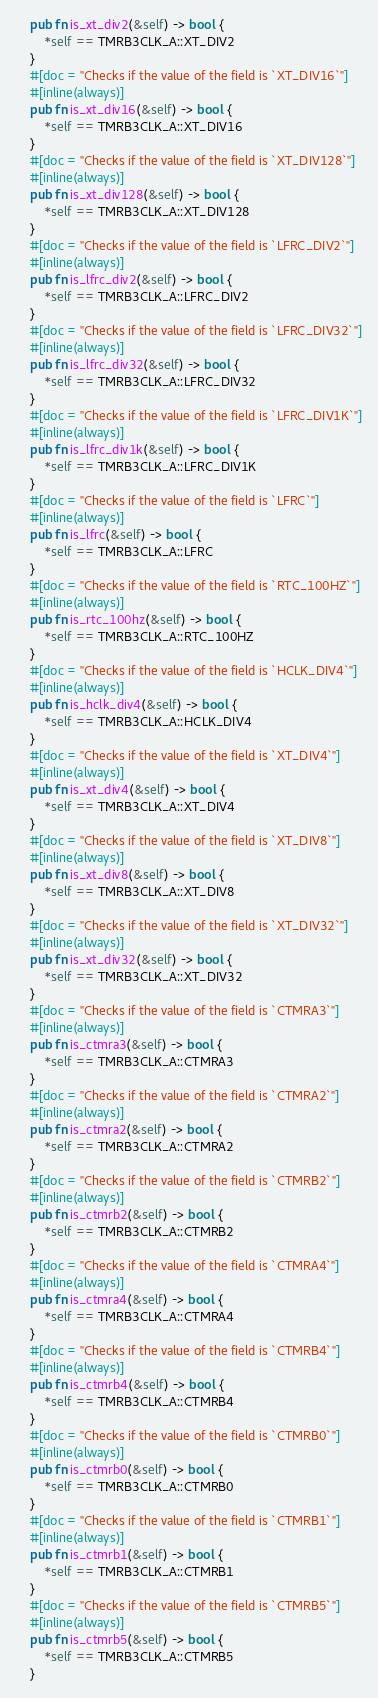<code> <loc_0><loc_0><loc_500><loc_500><_Rust_>    pub fn is_xt_div2(&self) -> bool {
        *self == TMRB3CLK_A::XT_DIV2
    }
    #[doc = "Checks if the value of the field is `XT_DIV16`"]
    #[inline(always)]
    pub fn is_xt_div16(&self) -> bool {
        *self == TMRB3CLK_A::XT_DIV16
    }
    #[doc = "Checks if the value of the field is `XT_DIV128`"]
    #[inline(always)]
    pub fn is_xt_div128(&self) -> bool {
        *self == TMRB3CLK_A::XT_DIV128
    }
    #[doc = "Checks if the value of the field is `LFRC_DIV2`"]
    #[inline(always)]
    pub fn is_lfrc_div2(&self) -> bool {
        *self == TMRB3CLK_A::LFRC_DIV2
    }
    #[doc = "Checks if the value of the field is `LFRC_DIV32`"]
    #[inline(always)]
    pub fn is_lfrc_div32(&self) -> bool {
        *self == TMRB3CLK_A::LFRC_DIV32
    }
    #[doc = "Checks if the value of the field is `LFRC_DIV1K`"]
    #[inline(always)]
    pub fn is_lfrc_div1k(&self) -> bool {
        *self == TMRB3CLK_A::LFRC_DIV1K
    }
    #[doc = "Checks if the value of the field is `LFRC`"]
    #[inline(always)]
    pub fn is_lfrc(&self) -> bool {
        *self == TMRB3CLK_A::LFRC
    }
    #[doc = "Checks if the value of the field is `RTC_100HZ`"]
    #[inline(always)]
    pub fn is_rtc_100hz(&self) -> bool {
        *self == TMRB3CLK_A::RTC_100HZ
    }
    #[doc = "Checks if the value of the field is `HCLK_DIV4`"]
    #[inline(always)]
    pub fn is_hclk_div4(&self) -> bool {
        *self == TMRB3CLK_A::HCLK_DIV4
    }
    #[doc = "Checks if the value of the field is `XT_DIV4`"]
    #[inline(always)]
    pub fn is_xt_div4(&self) -> bool {
        *self == TMRB3CLK_A::XT_DIV4
    }
    #[doc = "Checks if the value of the field is `XT_DIV8`"]
    #[inline(always)]
    pub fn is_xt_div8(&self) -> bool {
        *self == TMRB3CLK_A::XT_DIV8
    }
    #[doc = "Checks if the value of the field is `XT_DIV32`"]
    #[inline(always)]
    pub fn is_xt_div32(&self) -> bool {
        *self == TMRB3CLK_A::XT_DIV32
    }
    #[doc = "Checks if the value of the field is `CTMRA3`"]
    #[inline(always)]
    pub fn is_ctmra3(&self) -> bool {
        *self == TMRB3CLK_A::CTMRA3
    }
    #[doc = "Checks if the value of the field is `CTMRA2`"]
    #[inline(always)]
    pub fn is_ctmra2(&self) -> bool {
        *self == TMRB3CLK_A::CTMRA2
    }
    #[doc = "Checks if the value of the field is `CTMRB2`"]
    #[inline(always)]
    pub fn is_ctmrb2(&self) -> bool {
        *self == TMRB3CLK_A::CTMRB2
    }
    #[doc = "Checks if the value of the field is `CTMRA4`"]
    #[inline(always)]
    pub fn is_ctmra4(&self) -> bool {
        *self == TMRB3CLK_A::CTMRA4
    }
    #[doc = "Checks if the value of the field is `CTMRB4`"]
    #[inline(always)]
    pub fn is_ctmrb4(&self) -> bool {
        *self == TMRB3CLK_A::CTMRB4
    }
    #[doc = "Checks if the value of the field is `CTMRB0`"]
    #[inline(always)]
    pub fn is_ctmrb0(&self) -> bool {
        *self == TMRB3CLK_A::CTMRB0
    }
    #[doc = "Checks if the value of the field is `CTMRB1`"]
    #[inline(always)]
    pub fn is_ctmrb1(&self) -> bool {
        *self == TMRB3CLK_A::CTMRB1
    }
    #[doc = "Checks if the value of the field is `CTMRB5`"]
    #[inline(always)]
    pub fn is_ctmrb5(&self) -> bool {
        *self == TMRB3CLK_A::CTMRB5
    }</code> 